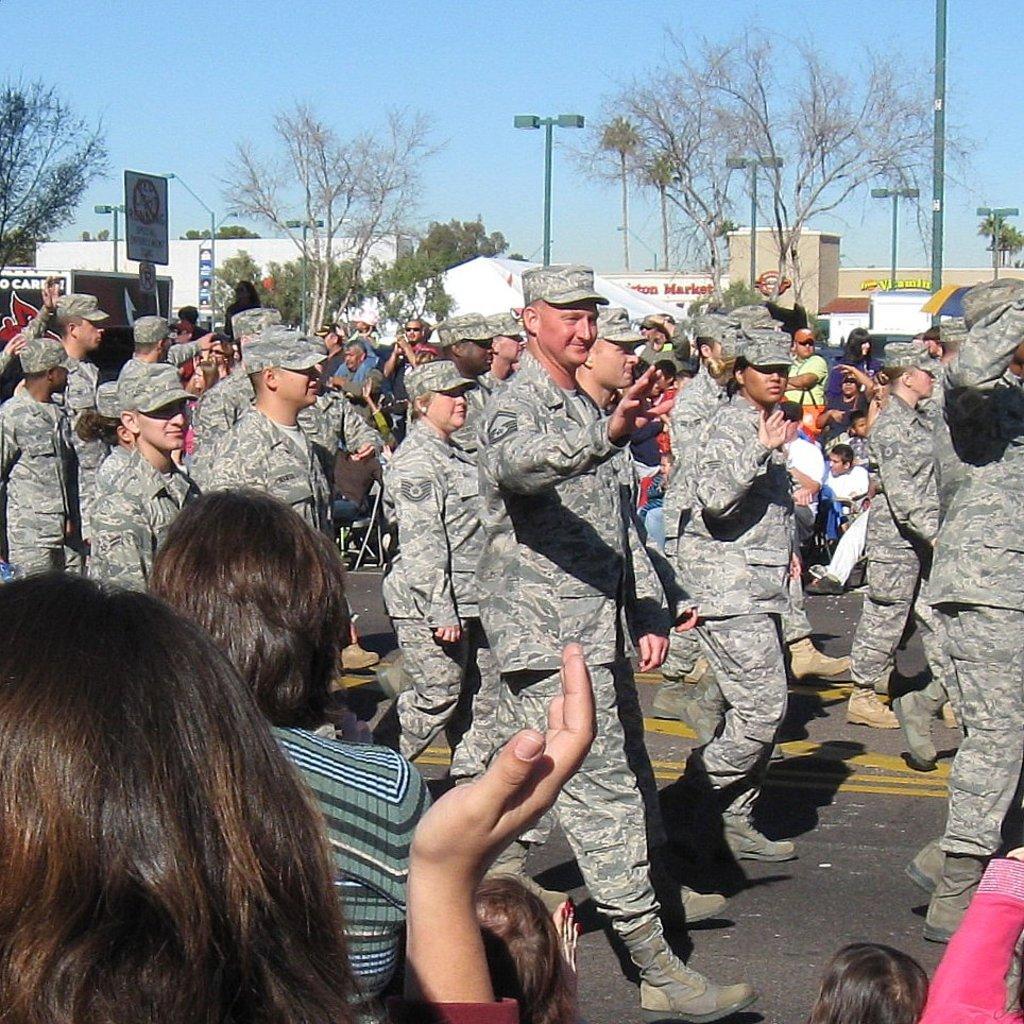Describe this image in one or two sentences. On the left side, there are persons. In the background, there are persons in uniform, walking on the road on which, there are yellow color lines, there are persons watching them, there are poles, there are trees, there are buildings and there is blue sky. 